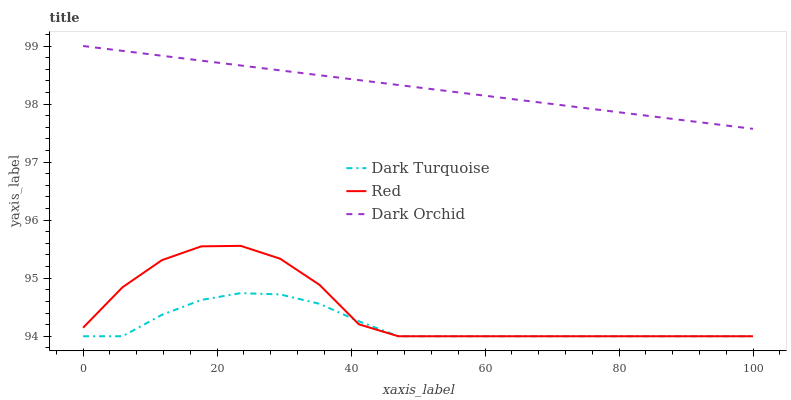Does Dark Turquoise have the minimum area under the curve?
Answer yes or no. Yes. Does Dark Orchid have the maximum area under the curve?
Answer yes or no. Yes. Does Red have the minimum area under the curve?
Answer yes or no. No. Does Red have the maximum area under the curve?
Answer yes or no. No. Is Dark Orchid the smoothest?
Answer yes or no. Yes. Is Red the roughest?
Answer yes or no. Yes. Is Red the smoothest?
Answer yes or no. No. Is Dark Orchid the roughest?
Answer yes or no. No. Does Dark Turquoise have the lowest value?
Answer yes or no. Yes. Does Dark Orchid have the lowest value?
Answer yes or no. No. Does Dark Orchid have the highest value?
Answer yes or no. Yes. Does Red have the highest value?
Answer yes or no. No. Is Red less than Dark Orchid?
Answer yes or no. Yes. Is Dark Orchid greater than Dark Turquoise?
Answer yes or no. Yes. Does Red intersect Dark Turquoise?
Answer yes or no. Yes. Is Red less than Dark Turquoise?
Answer yes or no. No. Is Red greater than Dark Turquoise?
Answer yes or no. No. Does Red intersect Dark Orchid?
Answer yes or no. No. 